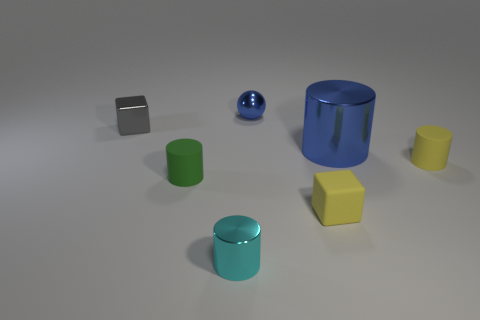Add 3 tiny cyan cylinders. How many objects exist? 10 Subtract all cubes. How many objects are left? 5 Add 2 small cubes. How many small cubes exist? 4 Subtract 0 gray cylinders. How many objects are left? 7 Subtract all yellow metallic cylinders. Subtract all cyan shiny cylinders. How many objects are left? 6 Add 5 tiny yellow things. How many tiny yellow things are left? 7 